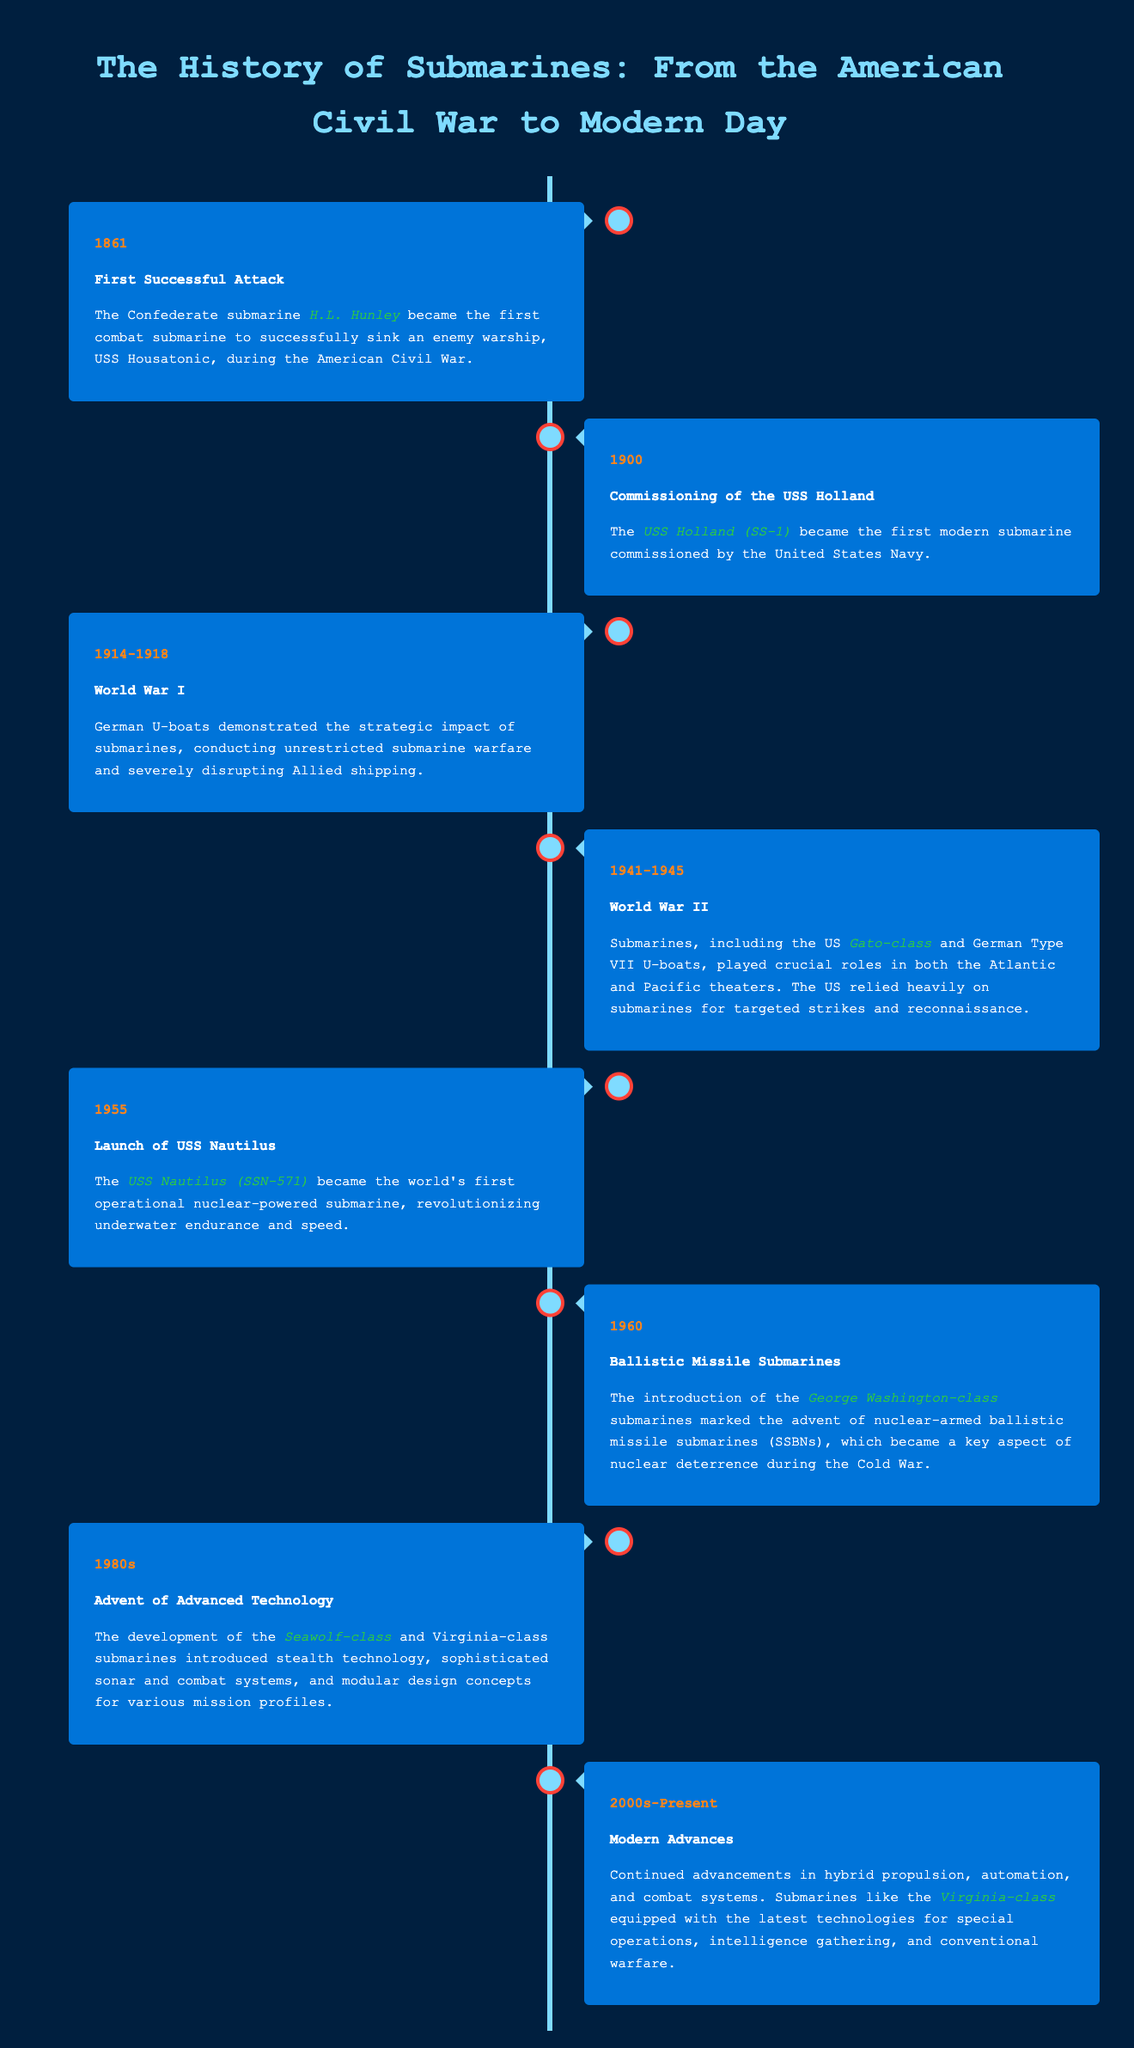What was the first combat submarine to sink an enemy warship? The document states that the Confederate submarine H.L. Hunley became the first combat submarine to successfully sink an enemy warship.
Answer: H.L. Hunley What year was the USS Holland commissioned? According to the timeline, the USS Holland was the first modern submarine commissioned by the United States Navy in 1900.
Answer: 1900 Which submarine class was the first operational nuclear-powered submarine? The document highlights that the USS Nautilus was the world's first operational nuclear-powered submarine, launched in 1955.
Answer: USS Nautilus What major global conflict saw the use of German U-boats? The timeline indicates that submarines, particularly German U-boats, played a strategic role during World War I.
Answer: World War I Which class of submarines marked the advent of nuclear-armed ballistic missile submarines? The document mentions the George Washington-class submarines as key in the introduction of nuclear-armed ballistic missile submarines.
Answer: George Washington-class What decade marked the development of the Seawolf-class submarines? The timeline states that the advent of advanced technology, including the Seawolf-class submarines, occurred in the 1980s.
Answer: 1980s What is a key feature of modern submarines according to the timeline? The document notes that modern submarines have advancements in hybrid propulsion, automation, and combat systems.
Answer: Hybrid propulsion Which submarine was crucial in World War II for the US Navy? The timeline references the Gato-class submarines as playing a crucial role in World War II for the US Navy.
Answer: Gato-class What year did the USS Nautilus launch? The document specifies that the USS Nautilus was launched in 1955, becoming the first operational nuclear-powered submarine.
Answer: 1955 